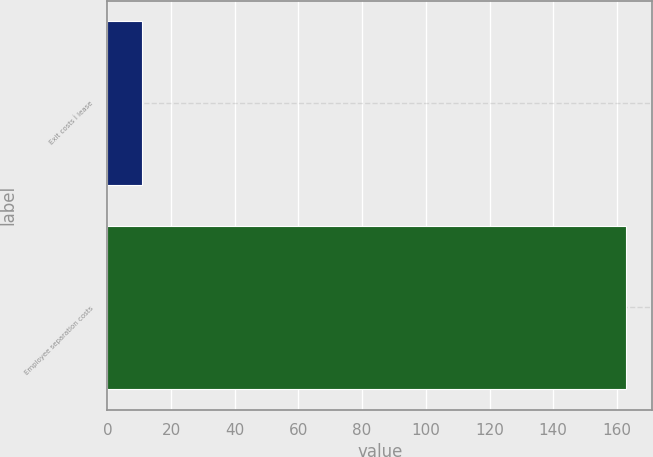Convert chart. <chart><loc_0><loc_0><loc_500><loc_500><bar_chart><fcel>Exit costs Ì lease<fcel>Employee separation costs<nl><fcel>11<fcel>163<nl></chart> 